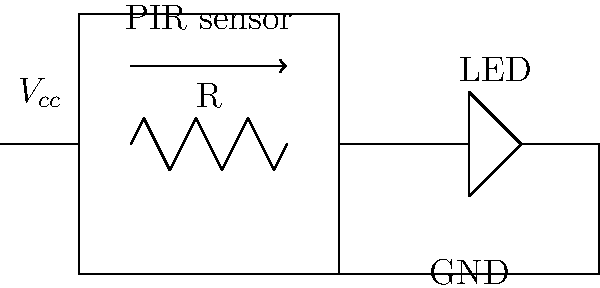In designing a simple motion sensor circuit to detect bird activity at your Great Dunmow feeding station, you decide to use a PIR (Passive Infrared) sensor. If the sensor's output goes high when motion is detected, and you want to illuminate an LED indicator, what is the primary purpose of the resistor R in the circuit shown? To understand the purpose of the resistor R in this circuit, let's break down the components and their functions:

1. PIR Sensor: Detects infrared radiation changes caused by motion, outputting a high signal when motion is detected.

2. LED: Illuminates when current flows through it, indicating detected motion.

3. Resistor R: Connected in series with the LED.

The primary purpose of the resistor R is to limit the current flowing through the LED. This is necessary because:

a) LEDs have a relatively low forward voltage drop (typically 1.8V to 3.3V, depending on color).

b) The voltage source ($V_{cc}$) is likely higher than the LED's forward voltage (usually 5V or 3.3V in microcontroller circuits).

c) Without a current-limiting resistor, the LED would draw excessive current, potentially damaging or destroying it.

The value of R can be calculated using Ohm's Law:

$$ R = \frac{V_{cc} - V_f}{I_f} $$

Where:
$V_{cc}$ is the supply voltage
$V_f$ is the LED's forward voltage
$I_f$ is the desired forward current through the LED

For example, if $V_{cc} = 5V$, $V_f = 2V$, and the desired $I_f = 20mA$, then:

$$ R = \frac{5V - 2V}{0.02A} = 150\Omega $$

This resistor protects the LED and ensures proper operation of the circuit when bird activity triggers the PIR sensor.
Answer: To limit current through the LED 